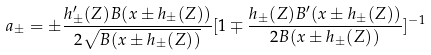<formula> <loc_0><loc_0><loc_500><loc_500>a _ { \pm } = \pm \frac { h ^ { \prime } _ { \pm } ( Z ) B ( x \pm h _ { \pm } ( Z ) ) } { 2 \sqrt { B ( x \pm h _ { \pm } ( Z ) ) } } [ 1 \mp \frac { h _ { \pm } ( Z ) B ^ { \prime } ( x \pm h _ { \pm } ( Z ) ) } { 2 B ( x \pm h _ { \pm } ( Z ) ) } ] ^ { - 1 }</formula> 